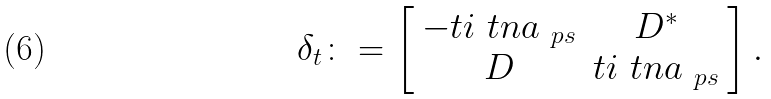<formula> <loc_0><loc_0><loc_500><loc_500>\delta _ { t } \colon = \left [ \begin{array} { c c } - t i \ t n a _ { \ p s } & D ^ { * } \\ D & t i \ t n a _ { \ p s } \end{array} \right ] .</formula> 